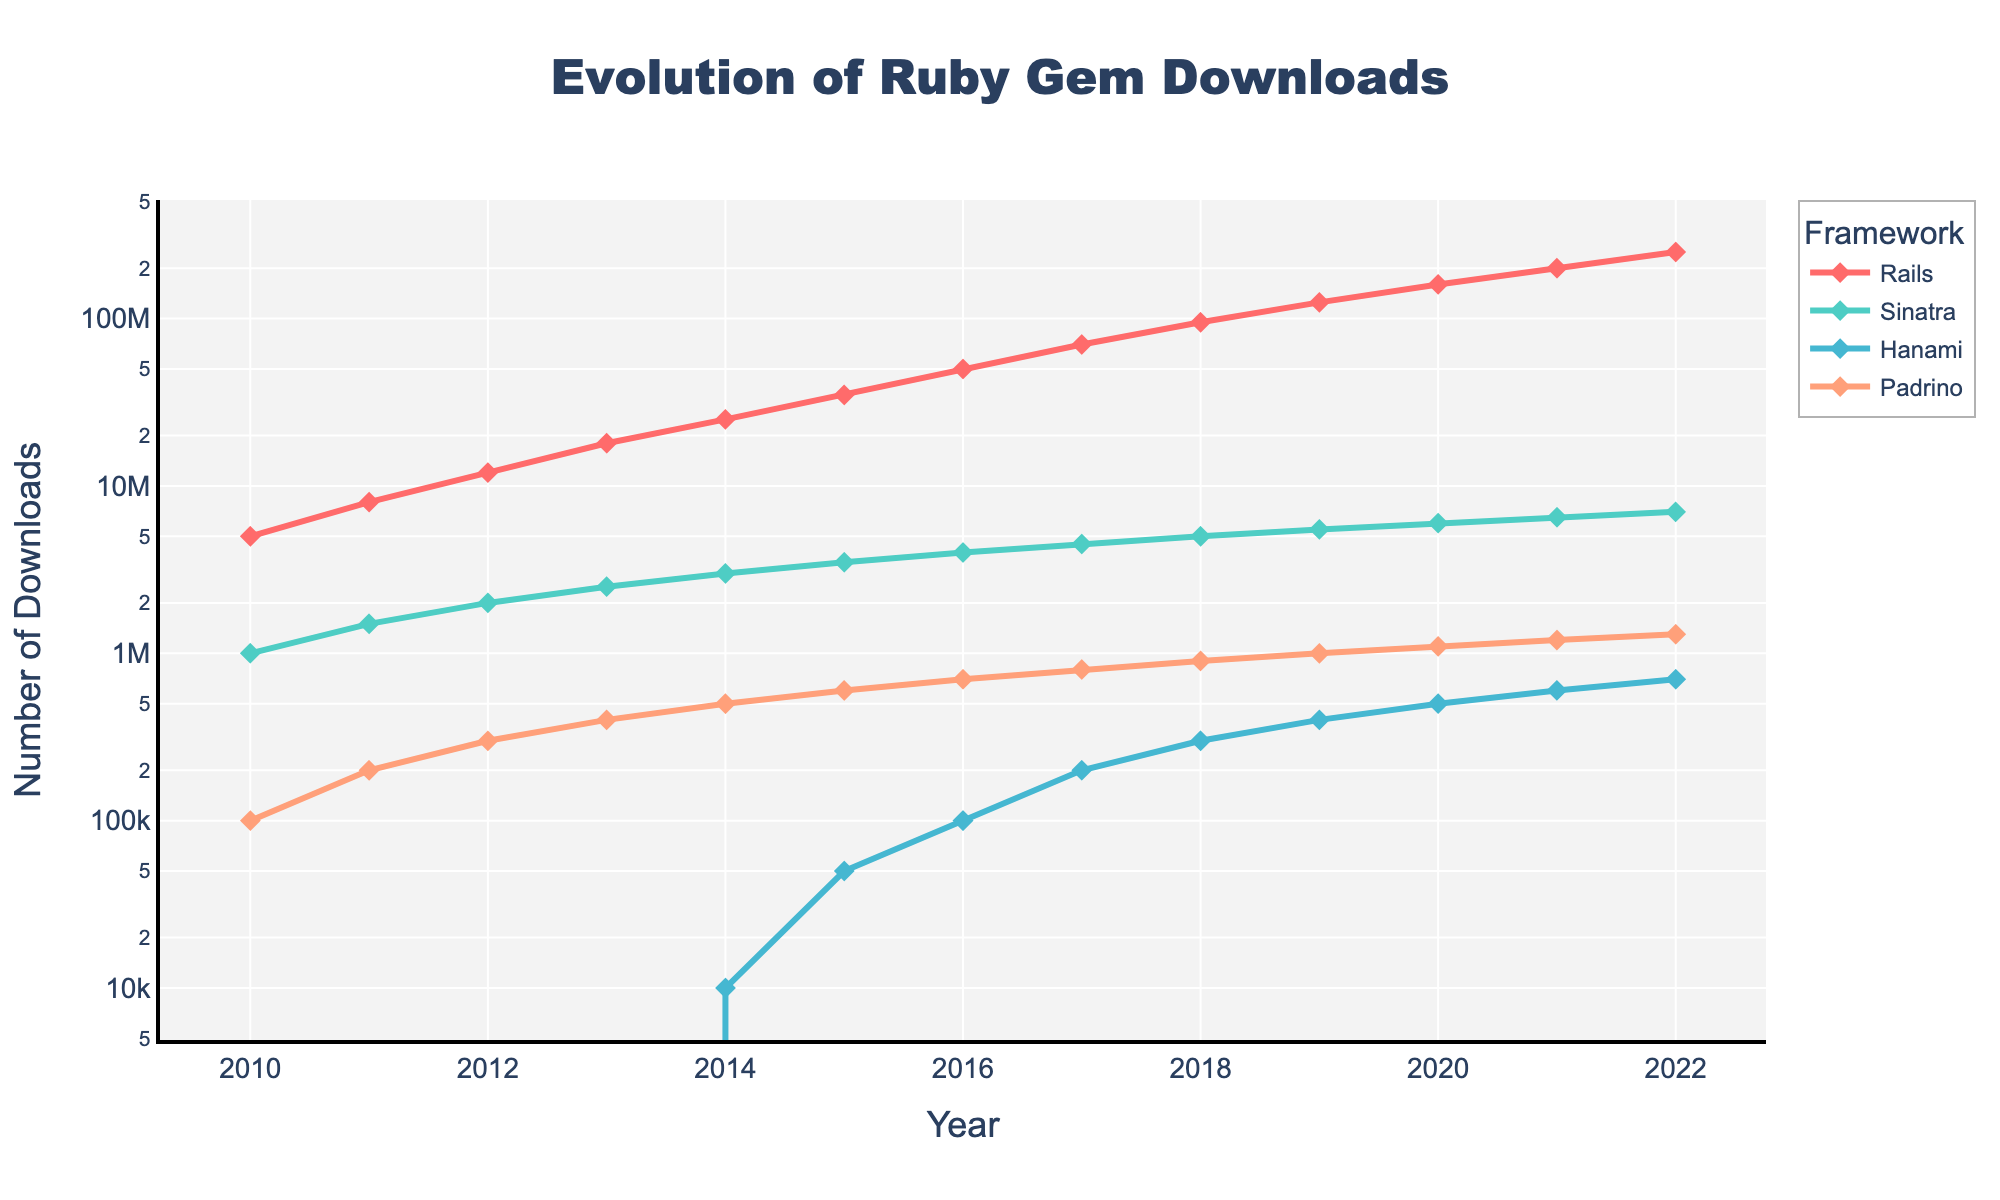Which framework had the most downloads in 2022? To find the framework with the most downloads in 2022, look at the values for Rails, Sinatra, Hanami, and Padrino for the year 2022. Rails has the highest value.
Answer: Rails How many total downloads were there for Sinatra from 2010 to 2015? Sum the downloads for Sinatra from 2010 to 2015: 1000000 + 1500000 + 2000000 + 2500000 + 3000000 + 3500000 = 13500000
Answer: 13500000 Which framework showed the largest growth in downloads between 2011 and 2012? Compute the difference in downloads between 2011 and 2012 for each framework: Rails (4000000), Sinatra (500000), Hanami (0), Padrino (100000). Rails showed the largest growth.
Answer: Rails In what year did Hanami first exceed 100,000 downloads? Identify the first year when Hanami's downloads were greater than 100,000 by looking at the download values for each year. In 2016, Hanami had 100,000 downloads.
Answer: 2016 Compare the growth rate of downloads for Rails and Sinatra between 2019 and 2020. Which one grew faster? Calculate the growth rate for Rails and Sinatra from 2019 to 2020: Rails (160000000 - 125000000 = 35000000), Sinatra (6000000 - 5500000 = 500000). Rails grew by 35,000,000 while Sinatra grew only by 500,000, thus Rails grew faster.
Answer: Rails What is the combined number of downloads for all frameworks in 2018? Sum the downloads of all frameworks for the year 2018: 95000000 (Rails) + 5000000 (Sinatra) + 300000 (Hanami) + 900000 (Padrino) = 101700000
Answer: 101700000 Which framework had the least downloads in 2015? Look at the download values for all frameworks in 2015 and identify the smallest number: Hanami had 50,000 downloads, which is the least.
Answer: Hanami What is the average number of downloads for Padrino across all the years in the dataset? Calculate the average by summing all the Padrino downloads and dividing by the number of years: (100000+200000+300000+400000+500000+600000+700000+800000+900000+1000000+1100000+1200000+1300000)/13 = 684615
Answer: 684615 Which framework’s line in the chart is represented in green? Identify the framework whose data points are connected by a green line. Hanami's marker and line are green.
Answer: Hanami 